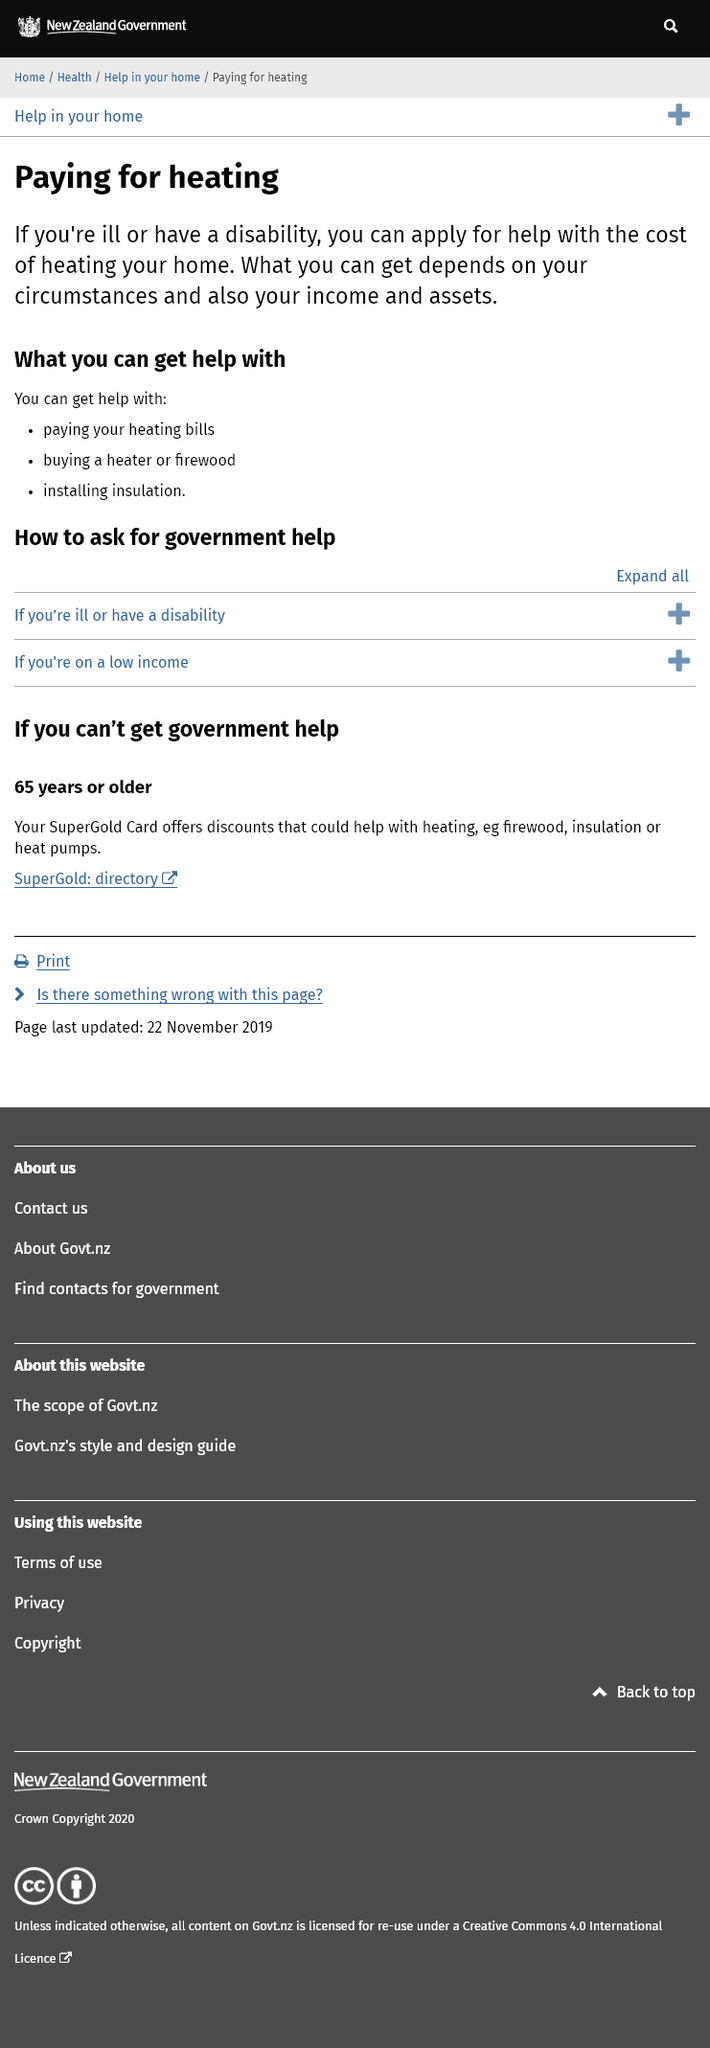Give some essential details in this illustration. Yes, it is possible for a disabled person to receive assistance in purchasing a heater. It is possible for a person who is ill to receive assistance with the installation of insulation. Income plays a significant role in determining the type of aid one can receive. 